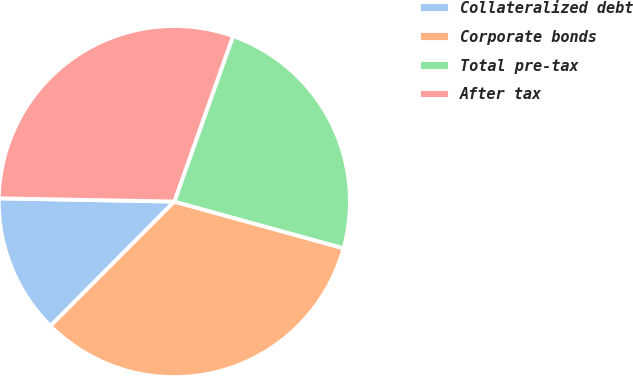Convert chart to OTSL. <chart><loc_0><loc_0><loc_500><loc_500><pie_chart><fcel>Collateralized debt<fcel>Corporate bonds<fcel>Total pre-tax<fcel>After tax<nl><fcel>12.83%<fcel>33.18%<fcel>23.86%<fcel>30.13%<nl></chart> 